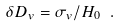<formula> <loc_0><loc_0><loc_500><loc_500>\delta D _ { v } = { \sigma _ { v } / H _ { 0 } } \ .</formula> 